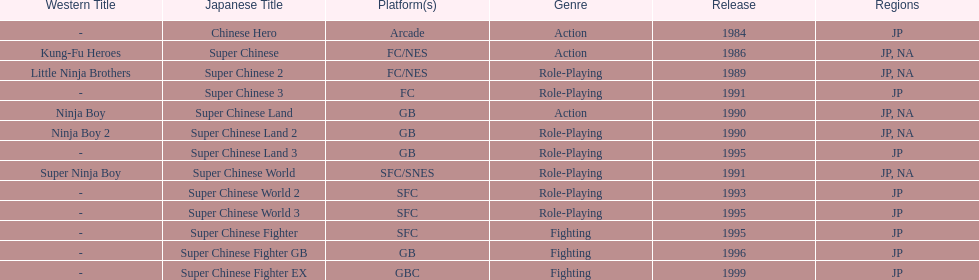What are the total of super chinese games released? 13. Could you parse the entire table? {'header': ['Western Title', 'Japanese Title', 'Platform(s)', 'Genre', 'Release', 'Regions'], 'rows': [['-', 'Chinese Hero', 'Arcade', 'Action', '1984', 'JP'], ['Kung-Fu Heroes', 'Super Chinese', 'FC/NES', 'Action', '1986', 'JP, NA'], ['Little Ninja Brothers', 'Super Chinese 2', 'FC/NES', 'Role-Playing', '1989', 'JP, NA'], ['-', 'Super Chinese 3', 'FC', 'Role-Playing', '1991', 'JP'], ['Ninja Boy', 'Super Chinese Land', 'GB', 'Action', '1990', 'JP, NA'], ['Ninja Boy 2', 'Super Chinese Land 2', 'GB', 'Role-Playing', '1990', 'JP, NA'], ['-', 'Super Chinese Land 3', 'GB', 'Role-Playing', '1995', 'JP'], ['Super Ninja Boy', 'Super Chinese World', 'SFC/SNES', 'Role-Playing', '1991', 'JP, NA'], ['-', 'Super Chinese World 2', 'SFC', 'Role-Playing', '1993', 'JP'], ['-', 'Super Chinese World 3', 'SFC', 'Role-Playing', '1995', 'JP'], ['-', 'Super Chinese Fighter', 'SFC', 'Fighting', '1995', 'JP'], ['-', 'Super Chinese Fighter GB', 'GB', 'Fighting', '1996', 'JP'], ['-', 'Super Chinese Fighter EX', 'GBC', 'Fighting', '1999', 'JP']]} 